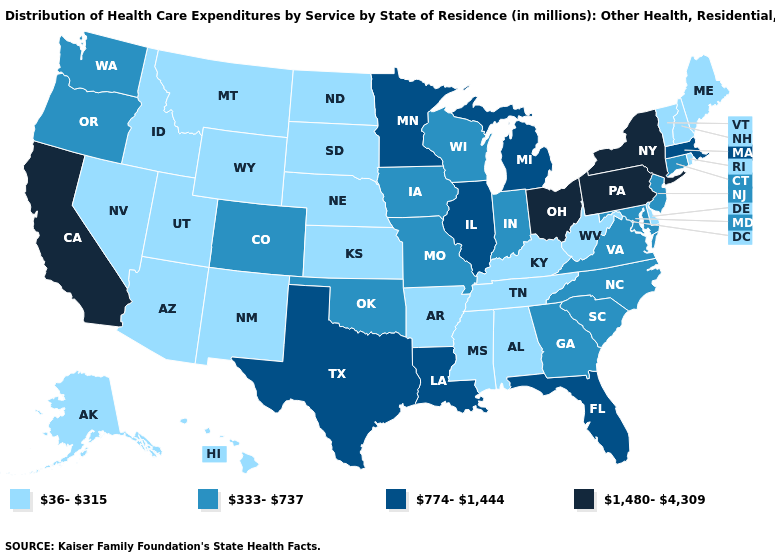Name the states that have a value in the range 333-737?
Be succinct. Colorado, Connecticut, Georgia, Indiana, Iowa, Maryland, Missouri, New Jersey, North Carolina, Oklahoma, Oregon, South Carolina, Virginia, Washington, Wisconsin. Does the map have missing data?
Write a very short answer. No. Name the states that have a value in the range 774-1,444?
Short answer required. Florida, Illinois, Louisiana, Massachusetts, Michigan, Minnesota, Texas. Does Maine have the lowest value in the USA?
Concise answer only. Yes. Does North Dakota have a lower value than New Hampshire?
Concise answer only. No. What is the lowest value in states that border Maine?
Answer briefly. 36-315. Name the states that have a value in the range 774-1,444?
Concise answer only. Florida, Illinois, Louisiana, Massachusetts, Michigan, Minnesota, Texas. What is the value of Connecticut?
Concise answer only. 333-737. What is the value of Missouri?
Give a very brief answer. 333-737. What is the value of Arkansas?
Short answer required. 36-315. What is the value of Alaska?
Answer briefly. 36-315. Name the states that have a value in the range 774-1,444?
Concise answer only. Florida, Illinois, Louisiana, Massachusetts, Michigan, Minnesota, Texas. Among the states that border Alabama , does Georgia have the lowest value?
Write a very short answer. No. Which states hav the highest value in the MidWest?
Be succinct. Ohio. What is the value of Florida?
Answer briefly. 774-1,444. 